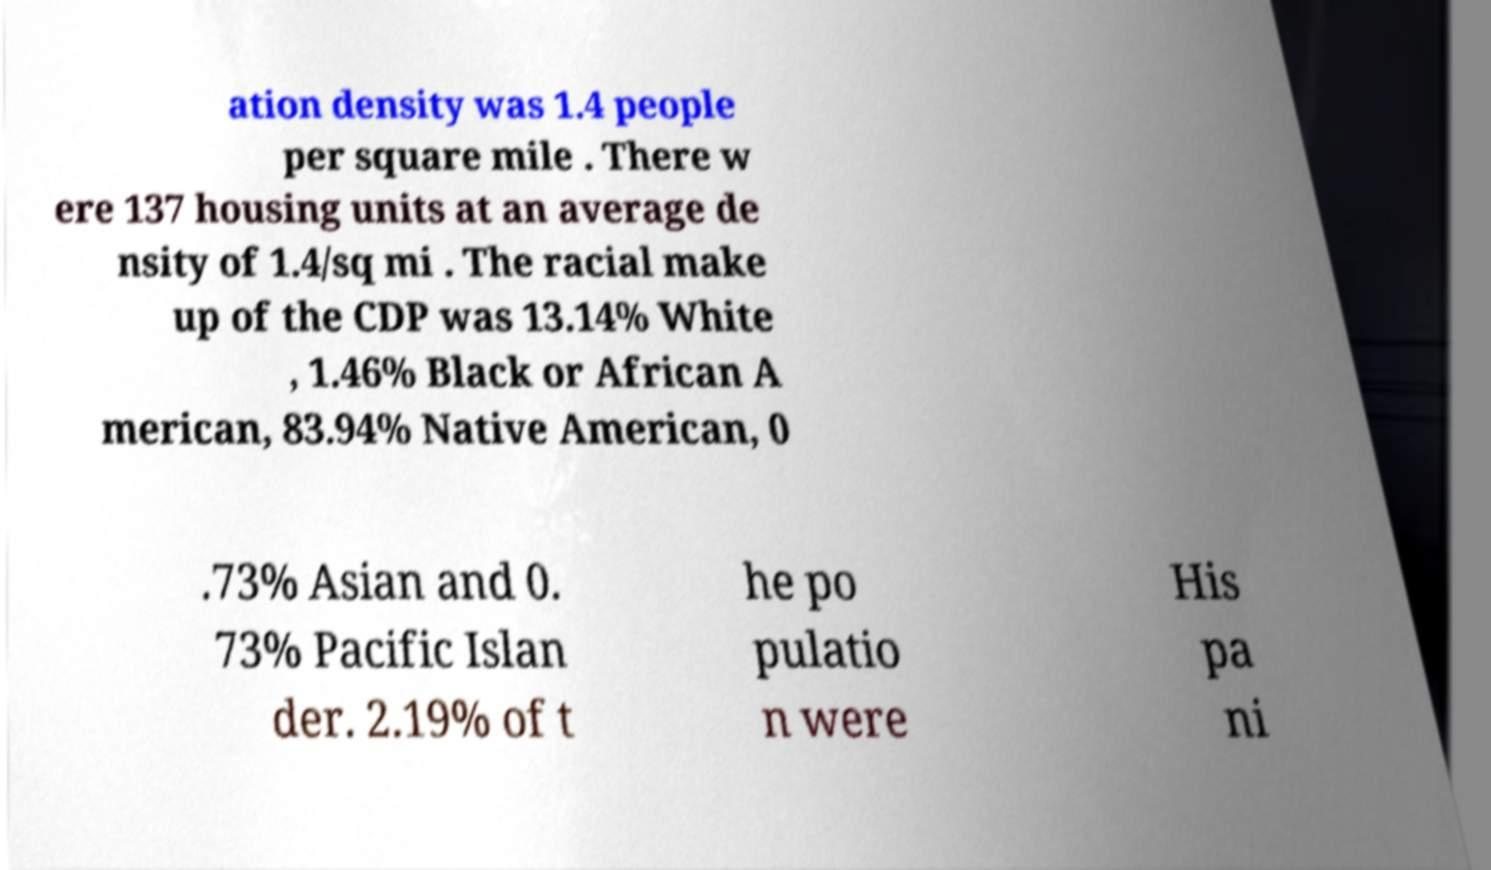Please identify and transcribe the text found in this image. ation density was 1.4 people per square mile . There w ere 137 housing units at an average de nsity of 1.4/sq mi . The racial make up of the CDP was 13.14% White , 1.46% Black or African A merican, 83.94% Native American, 0 .73% Asian and 0. 73% Pacific Islan der. 2.19% of t he po pulatio n were His pa ni 